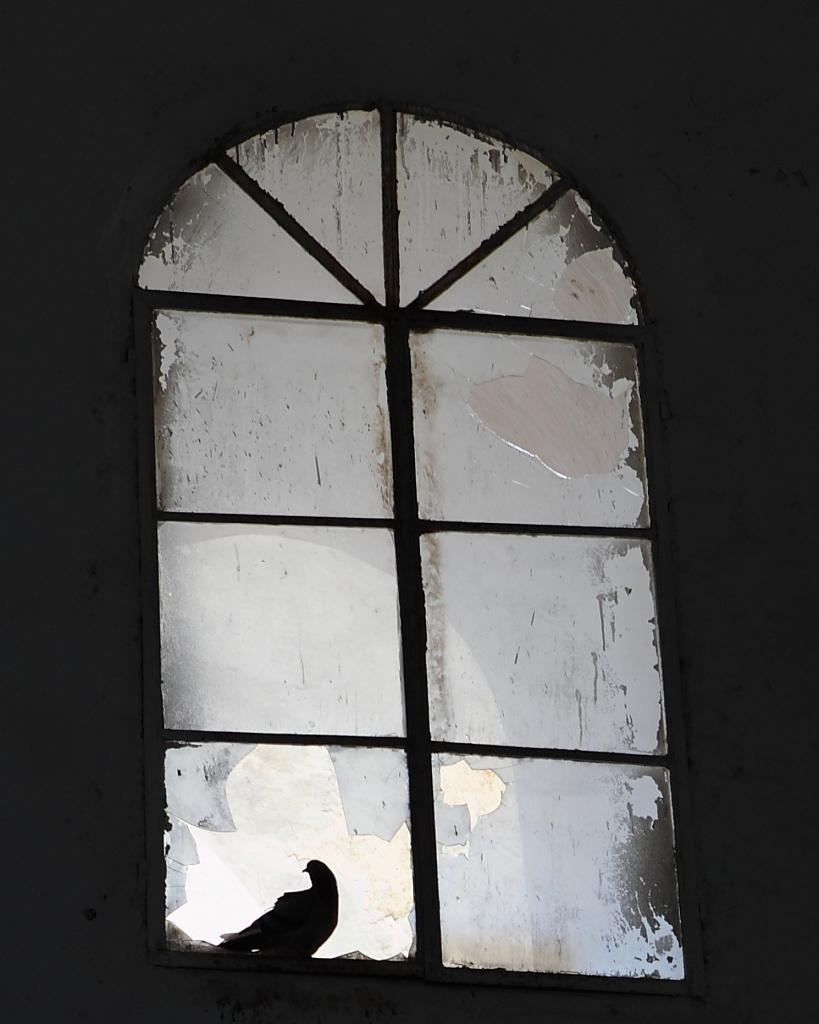What can be seen in the image that provides a view of the outside? There is a window in the image. What is the condition of the window? The window is broken. What type of animal is present in the image? A bird is standing in the image. What type of glue is being used to fix the broken window in the image? There is no glue present in the image, nor is there any indication that the window is being fixed. 